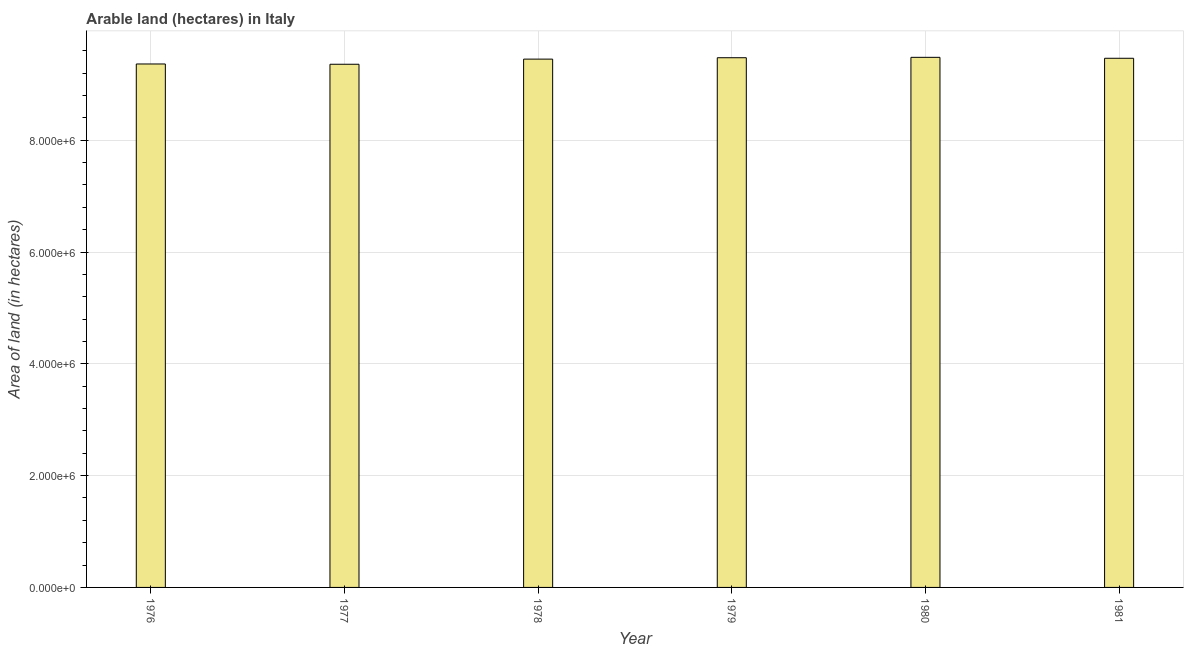Does the graph contain any zero values?
Offer a terse response. No. What is the title of the graph?
Keep it short and to the point. Arable land (hectares) in Italy. What is the label or title of the X-axis?
Offer a terse response. Year. What is the label or title of the Y-axis?
Offer a terse response. Area of land (in hectares). What is the area of land in 1979?
Give a very brief answer. 9.48e+06. Across all years, what is the maximum area of land?
Ensure brevity in your answer.  9.48e+06. Across all years, what is the minimum area of land?
Give a very brief answer. 9.36e+06. In which year was the area of land maximum?
Your answer should be compact. 1980. In which year was the area of land minimum?
Offer a terse response. 1977. What is the sum of the area of land?
Your response must be concise. 5.66e+07. What is the difference between the area of land in 1977 and 1981?
Provide a succinct answer. -1.07e+05. What is the average area of land per year?
Offer a terse response. 9.43e+06. What is the median area of land?
Give a very brief answer. 9.46e+06. In how many years, is the area of land greater than 2400000 hectares?
Offer a very short reply. 6. Do a majority of the years between 1977 and 1978 (inclusive) have area of land greater than 2400000 hectares?
Your response must be concise. Yes. What is the ratio of the area of land in 1977 to that in 1978?
Offer a terse response. 0.99. Is the difference between the area of land in 1977 and 1981 greater than the difference between any two years?
Offer a terse response. No. What is the difference between the highest and the second highest area of land?
Provide a succinct answer. 7000. Is the sum of the area of land in 1976 and 1980 greater than the maximum area of land across all years?
Provide a short and direct response. Yes. What is the difference between the highest and the lowest area of land?
Provide a short and direct response. 1.24e+05. Are the values on the major ticks of Y-axis written in scientific E-notation?
Your response must be concise. Yes. What is the Area of land (in hectares) of 1976?
Give a very brief answer. 9.36e+06. What is the Area of land (in hectares) of 1977?
Your answer should be compact. 9.36e+06. What is the Area of land (in hectares) of 1978?
Keep it short and to the point. 9.45e+06. What is the Area of land (in hectares) of 1979?
Keep it short and to the point. 9.48e+06. What is the Area of land (in hectares) of 1980?
Keep it short and to the point. 9.48e+06. What is the Area of land (in hectares) of 1981?
Your answer should be very brief. 9.47e+06. What is the difference between the Area of land (in hectares) in 1976 and 1978?
Provide a succinct answer. -8.70e+04. What is the difference between the Area of land (in hectares) in 1976 and 1979?
Provide a short and direct response. -1.12e+05. What is the difference between the Area of land (in hectares) in 1976 and 1980?
Your answer should be very brief. -1.19e+05. What is the difference between the Area of land (in hectares) in 1976 and 1981?
Ensure brevity in your answer.  -1.02e+05. What is the difference between the Area of land (in hectares) in 1977 and 1978?
Your response must be concise. -9.20e+04. What is the difference between the Area of land (in hectares) in 1977 and 1979?
Offer a very short reply. -1.17e+05. What is the difference between the Area of land (in hectares) in 1977 and 1980?
Make the answer very short. -1.24e+05. What is the difference between the Area of land (in hectares) in 1977 and 1981?
Your response must be concise. -1.07e+05. What is the difference between the Area of land (in hectares) in 1978 and 1979?
Provide a succinct answer. -2.50e+04. What is the difference between the Area of land (in hectares) in 1978 and 1980?
Provide a succinct answer. -3.20e+04. What is the difference between the Area of land (in hectares) in 1978 and 1981?
Your answer should be compact. -1.50e+04. What is the difference between the Area of land (in hectares) in 1979 and 1980?
Make the answer very short. -7000. What is the difference between the Area of land (in hectares) in 1980 and 1981?
Make the answer very short. 1.70e+04. What is the ratio of the Area of land (in hectares) in 1976 to that in 1977?
Offer a very short reply. 1. What is the ratio of the Area of land (in hectares) in 1976 to that in 1979?
Make the answer very short. 0.99. What is the ratio of the Area of land (in hectares) in 1976 to that in 1981?
Provide a short and direct response. 0.99. What is the ratio of the Area of land (in hectares) in 1977 to that in 1978?
Give a very brief answer. 0.99. What is the ratio of the Area of land (in hectares) in 1977 to that in 1979?
Give a very brief answer. 0.99. What is the ratio of the Area of land (in hectares) in 1978 to that in 1979?
Give a very brief answer. 1. What is the ratio of the Area of land (in hectares) in 1978 to that in 1981?
Provide a short and direct response. 1. What is the ratio of the Area of land (in hectares) in 1979 to that in 1980?
Keep it short and to the point. 1. What is the ratio of the Area of land (in hectares) in 1979 to that in 1981?
Ensure brevity in your answer.  1. What is the ratio of the Area of land (in hectares) in 1980 to that in 1981?
Your answer should be very brief. 1. 